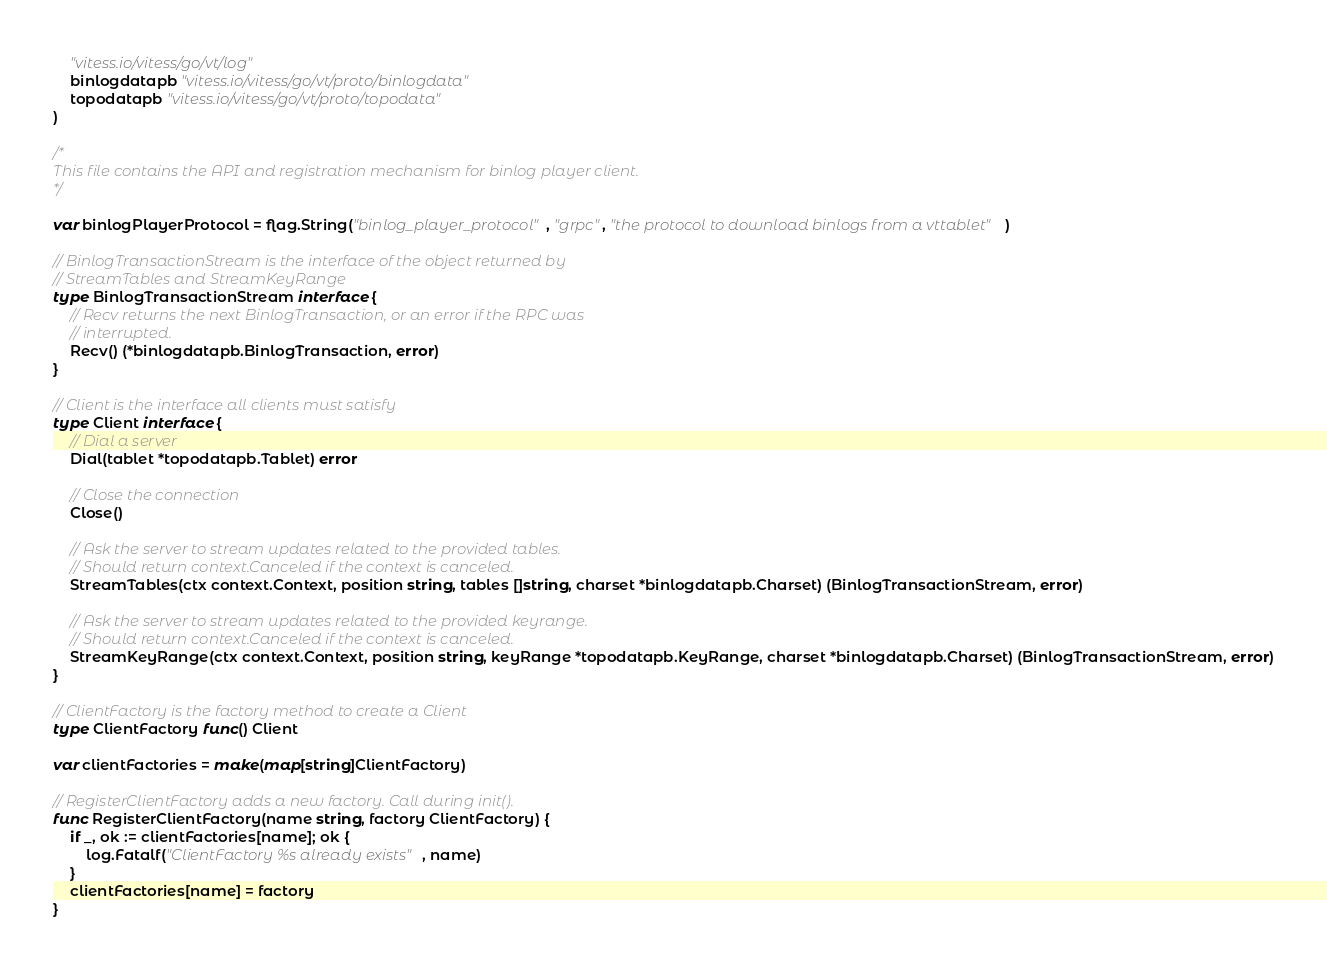Convert code to text. <code><loc_0><loc_0><loc_500><loc_500><_Go_>
	"vitess.io/vitess/go/vt/log"
	binlogdatapb "vitess.io/vitess/go/vt/proto/binlogdata"
	topodatapb "vitess.io/vitess/go/vt/proto/topodata"
)

/*
This file contains the API and registration mechanism for binlog player client.
*/

var binlogPlayerProtocol = flag.String("binlog_player_protocol", "grpc", "the protocol to download binlogs from a vttablet")

// BinlogTransactionStream is the interface of the object returned by
// StreamTables and StreamKeyRange
type BinlogTransactionStream interface {
	// Recv returns the next BinlogTransaction, or an error if the RPC was
	// interrupted.
	Recv() (*binlogdatapb.BinlogTransaction, error)
}

// Client is the interface all clients must satisfy
type Client interface {
	// Dial a server
	Dial(tablet *topodatapb.Tablet) error

	// Close the connection
	Close()

	// Ask the server to stream updates related to the provided tables.
	// Should return context.Canceled if the context is canceled.
	StreamTables(ctx context.Context, position string, tables []string, charset *binlogdatapb.Charset) (BinlogTransactionStream, error)

	// Ask the server to stream updates related to the provided keyrange.
	// Should return context.Canceled if the context is canceled.
	StreamKeyRange(ctx context.Context, position string, keyRange *topodatapb.KeyRange, charset *binlogdatapb.Charset) (BinlogTransactionStream, error)
}

// ClientFactory is the factory method to create a Client
type ClientFactory func() Client

var clientFactories = make(map[string]ClientFactory)

// RegisterClientFactory adds a new factory. Call during init().
func RegisterClientFactory(name string, factory ClientFactory) {
	if _, ok := clientFactories[name]; ok {
		log.Fatalf("ClientFactory %s already exists", name)
	}
	clientFactories[name] = factory
}
</code> 